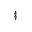<formula> <loc_0><loc_0><loc_500><loc_500>^ { \ddag }</formula> 